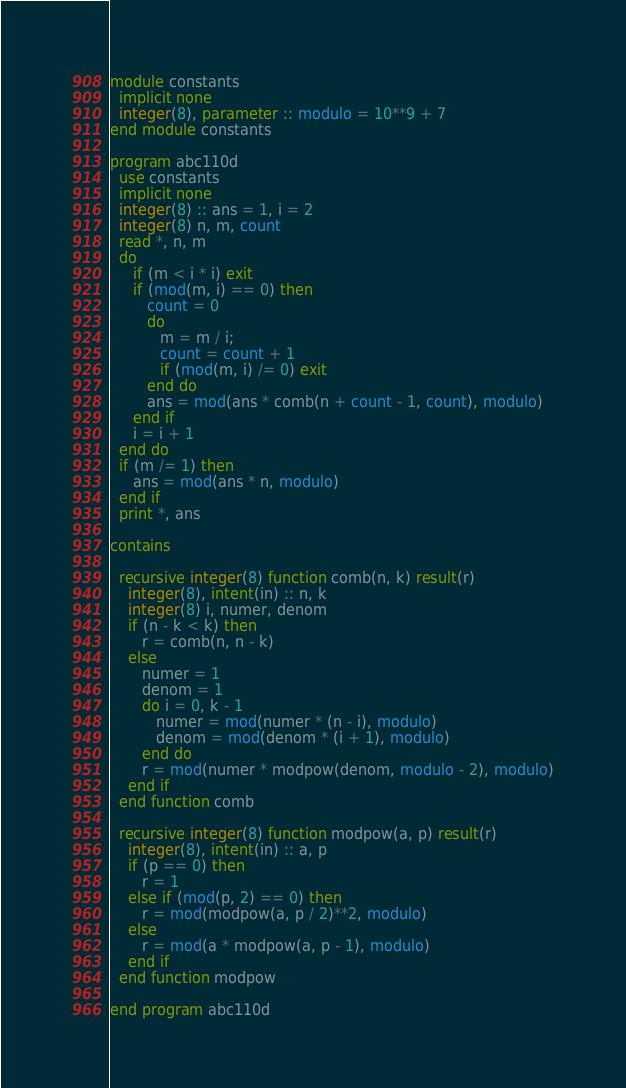<code> <loc_0><loc_0><loc_500><loc_500><_FORTRAN_>module constants
  implicit none
  integer(8), parameter :: modulo = 10**9 + 7
end module constants

program abc110d
  use constants
  implicit none
  integer(8) :: ans = 1, i = 2
  integer(8) n, m, count
  read *, n, m
  do
     if (m < i * i) exit
     if (mod(m, i) == 0) then
        count = 0
        do
           m = m / i;
           count = count + 1
           if (mod(m, i) /= 0) exit
        end do
        ans = mod(ans * comb(n + count - 1, count), modulo)
     end if
     i = i + 1
  end do
  if (m /= 1) then
     ans = mod(ans * n, modulo)
  end if
  print *, ans

contains

  recursive integer(8) function comb(n, k) result(r)
    integer(8), intent(in) :: n, k
    integer(8) i, numer, denom
    if (n - k < k) then
       r = comb(n, n - k)
    else
       numer = 1
       denom = 1
       do i = 0, k - 1
          numer = mod(numer * (n - i), modulo)
          denom = mod(denom * (i + 1), modulo)
       end do
       r = mod(numer * modpow(denom, modulo - 2), modulo)
    end if
  end function comb

  recursive integer(8) function modpow(a, p) result(r)
    integer(8), intent(in) :: a, p
    if (p == 0) then
       r = 1
    else if (mod(p, 2) == 0) then
       r = mod(modpow(a, p / 2)**2, modulo)
    else
       r = mod(a * modpow(a, p - 1), modulo)
    end if
  end function modpow

end program abc110d
</code> 